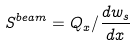Convert formula to latex. <formula><loc_0><loc_0><loc_500><loc_500>S ^ { b e a m } = Q _ { x } / \frac { d w _ { s } } { d x }</formula> 